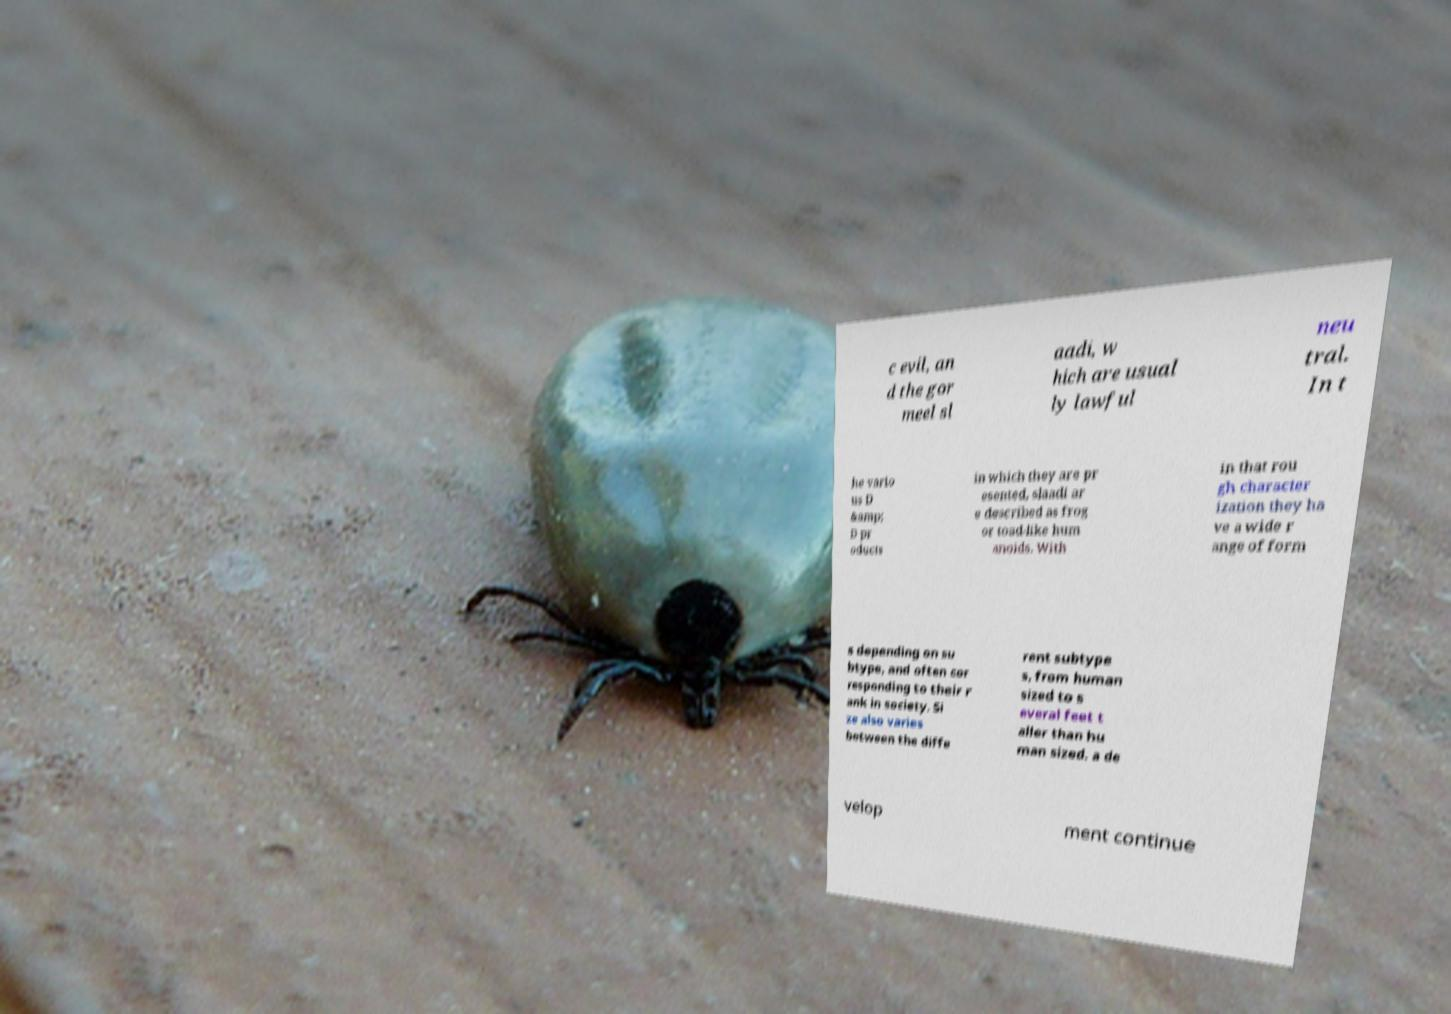There's text embedded in this image that I need extracted. Can you transcribe it verbatim? c evil, an d the gor meel sl aadi, w hich are usual ly lawful neu tral. In t he vario us D &amp; D pr oducts in which they are pr esented, slaadi ar e described as frog or toad-like hum anoids. With in that rou gh character ization they ha ve a wide r ange of form s depending on su btype, and often cor responding to their r ank in society. Si ze also varies between the diffe rent subtype s, from human sized to s everal feet t aller than hu man sized. a de velop ment continue 